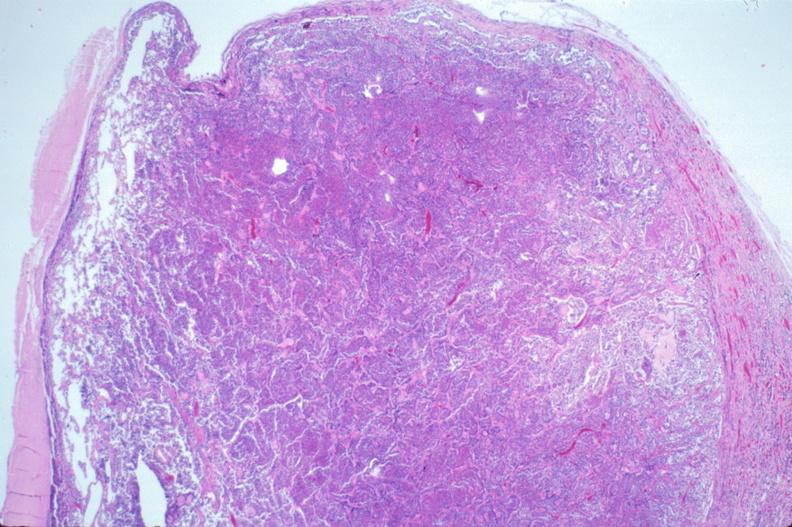where is this part in the figure?
Answer the question using a single word or phrase. Endocrine system 